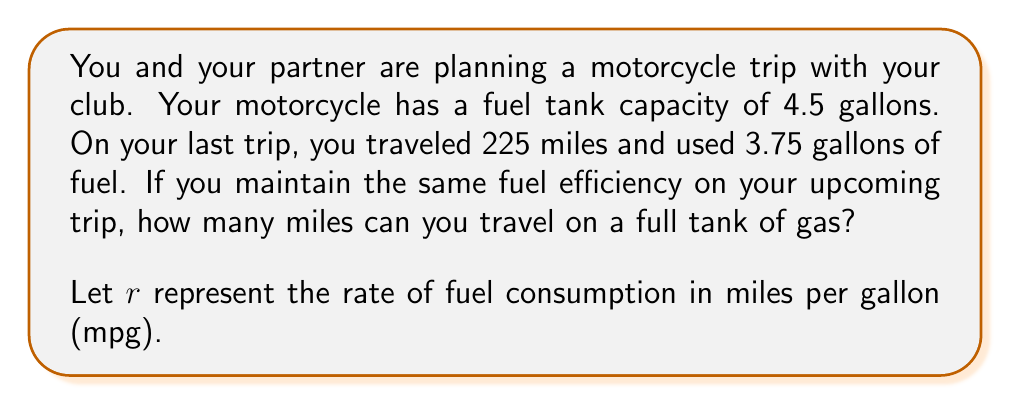Teach me how to tackle this problem. To solve this problem, we'll use rate equations and follow these steps:

1) First, let's calculate the fuel efficiency (rate) from the given information:
   
   $r = \frac{\text{distance traveled}}{\text{fuel consumed}}$
   
   $r = \frac{225 \text{ miles}}{3.75 \text{ gallons}} = 60 \text{ mpg}$

2) Now that we know the fuel efficiency, we can use this rate to determine how far we can travel on a full tank.

3) Let's set up an equation:
   
   $\text{distance} = \text{rate} \times \text{fuel amount}$
   
   $d = r \times f$

4) We know $r = 60 \text{ mpg}$ and a full tank is 4.5 gallons. Let's substitute these values:

   $d = 60 \text{ mpg} \times 4.5 \text{ gallons}$

5) Now we can solve for $d$:

   $d = 60 \times 4.5 = 270 \text{ miles}$

Therefore, on a full tank of gas (4.5 gallons) at the same fuel efficiency (60 mpg), you can travel 270 miles.
Answer: 270 miles 